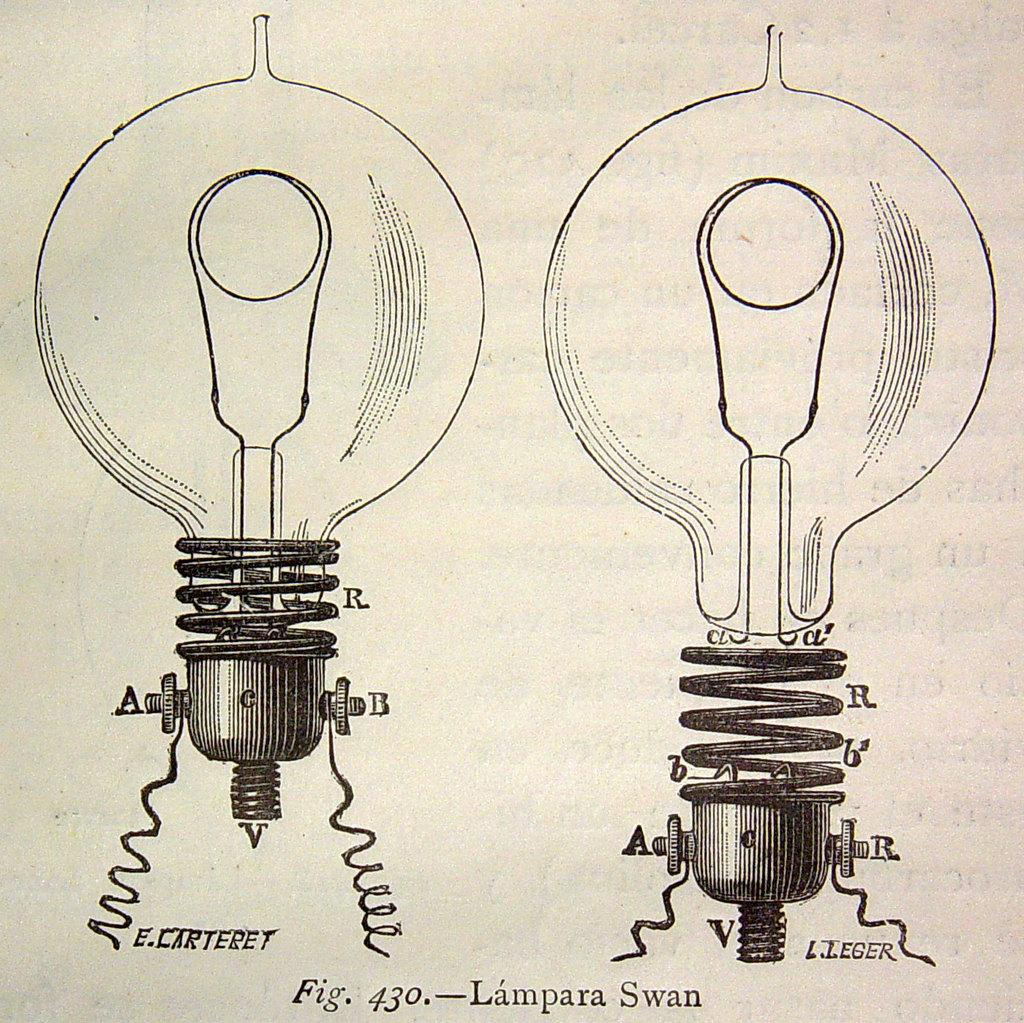What is the medium of the image? The image might be a painting on paper. What objects can be seen in the image? There are two bulbs in the image. Is there any text present in the image? Yes, there is text written on the paper in the image. What type of boot is being used for comfort in the image? There is no boot present in the image. How many baskets can be seen in the image? There are no baskets present in the image. 